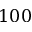<formula> <loc_0><loc_0><loc_500><loc_500>1 0 0</formula> 